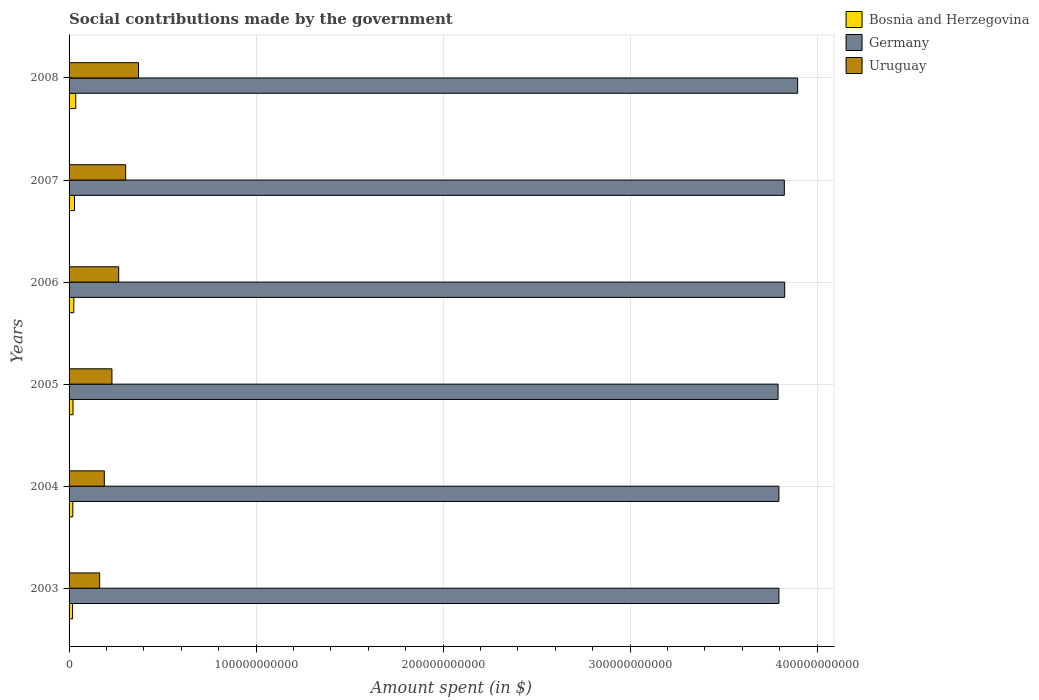Are the number of bars on each tick of the Y-axis equal?
Make the answer very short. Yes. What is the label of the 6th group of bars from the top?
Provide a short and direct response. 2003. In how many cases, is the number of bars for a given year not equal to the number of legend labels?
Offer a terse response. 0. What is the amount spent on social contributions in Bosnia and Herzegovina in 2005?
Give a very brief answer. 2.10e+09. Across all years, what is the maximum amount spent on social contributions in Germany?
Give a very brief answer. 3.90e+11. Across all years, what is the minimum amount spent on social contributions in Bosnia and Herzegovina?
Give a very brief answer. 1.88e+09. In which year was the amount spent on social contributions in Germany minimum?
Offer a terse response. 2005. What is the total amount spent on social contributions in Bosnia and Herzegovina in the graph?
Your answer should be very brief. 1.50e+1. What is the difference between the amount spent on social contributions in Uruguay in 2003 and that in 2007?
Make the answer very short. -1.39e+1. What is the difference between the amount spent on social contributions in Germany in 2004 and the amount spent on social contributions in Bosnia and Herzegovina in 2006?
Your answer should be very brief. 3.77e+11. What is the average amount spent on social contributions in Uruguay per year?
Your response must be concise. 2.53e+1. In the year 2004, what is the difference between the amount spent on social contributions in Bosnia and Herzegovina and amount spent on social contributions in Germany?
Your answer should be compact. -3.78e+11. What is the ratio of the amount spent on social contributions in Bosnia and Herzegovina in 2004 to that in 2006?
Offer a terse response. 0.79. Is the amount spent on social contributions in Uruguay in 2007 less than that in 2008?
Offer a terse response. Yes. Is the difference between the amount spent on social contributions in Bosnia and Herzegovina in 2005 and 2007 greater than the difference between the amount spent on social contributions in Germany in 2005 and 2007?
Offer a very short reply. Yes. What is the difference between the highest and the second highest amount spent on social contributions in Germany?
Your response must be concise. 6.92e+09. What is the difference between the highest and the lowest amount spent on social contributions in Uruguay?
Give a very brief answer. 2.08e+1. Is the sum of the amount spent on social contributions in Germany in 2003 and 2007 greater than the maximum amount spent on social contributions in Uruguay across all years?
Provide a succinct answer. Yes. What does the 3rd bar from the top in 2003 represents?
Provide a short and direct response. Bosnia and Herzegovina. Are all the bars in the graph horizontal?
Your response must be concise. Yes. How many years are there in the graph?
Offer a very short reply. 6. What is the difference between two consecutive major ticks on the X-axis?
Offer a terse response. 1.00e+11. Are the values on the major ticks of X-axis written in scientific E-notation?
Provide a short and direct response. No. Does the graph contain any zero values?
Keep it short and to the point. No. What is the title of the graph?
Make the answer very short. Social contributions made by the government. What is the label or title of the X-axis?
Give a very brief answer. Amount spent (in $). What is the Amount spent (in $) in Bosnia and Herzegovina in 2003?
Provide a short and direct response. 1.88e+09. What is the Amount spent (in $) of Germany in 2003?
Offer a terse response. 3.80e+11. What is the Amount spent (in $) of Uruguay in 2003?
Your answer should be very brief. 1.64e+1. What is the Amount spent (in $) in Bosnia and Herzegovina in 2004?
Your answer should be very brief. 2.00e+09. What is the Amount spent (in $) in Germany in 2004?
Ensure brevity in your answer.  3.80e+11. What is the Amount spent (in $) in Uruguay in 2004?
Your answer should be compact. 1.88e+1. What is the Amount spent (in $) of Bosnia and Herzegovina in 2005?
Provide a succinct answer. 2.10e+09. What is the Amount spent (in $) in Germany in 2005?
Provide a succinct answer. 3.79e+11. What is the Amount spent (in $) in Uruguay in 2005?
Give a very brief answer. 2.29e+1. What is the Amount spent (in $) in Bosnia and Herzegovina in 2006?
Offer a terse response. 2.54e+09. What is the Amount spent (in $) in Germany in 2006?
Offer a very short reply. 3.83e+11. What is the Amount spent (in $) of Uruguay in 2006?
Keep it short and to the point. 2.65e+1. What is the Amount spent (in $) of Bosnia and Herzegovina in 2007?
Your answer should be compact. 2.91e+09. What is the Amount spent (in $) in Germany in 2007?
Give a very brief answer. 3.82e+11. What is the Amount spent (in $) of Uruguay in 2007?
Ensure brevity in your answer.  3.03e+1. What is the Amount spent (in $) in Bosnia and Herzegovina in 2008?
Your answer should be compact. 3.57e+09. What is the Amount spent (in $) in Germany in 2008?
Make the answer very short. 3.90e+11. What is the Amount spent (in $) of Uruguay in 2008?
Provide a short and direct response. 3.71e+1. Across all years, what is the maximum Amount spent (in $) in Bosnia and Herzegovina?
Ensure brevity in your answer.  3.57e+09. Across all years, what is the maximum Amount spent (in $) in Germany?
Your answer should be compact. 3.90e+11. Across all years, what is the maximum Amount spent (in $) of Uruguay?
Your answer should be compact. 3.71e+1. Across all years, what is the minimum Amount spent (in $) of Bosnia and Herzegovina?
Provide a succinct answer. 1.88e+09. Across all years, what is the minimum Amount spent (in $) of Germany?
Provide a short and direct response. 3.79e+11. Across all years, what is the minimum Amount spent (in $) in Uruguay?
Ensure brevity in your answer.  1.64e+1. What is the total Amount spent (in $) in Bosnia and Herzegovina in the graph?
Your answer should be compact. 1.50e+1. What is the total Amount spent (in $) in Germany in the graph?
Give a very brief answer. 2.29e+12. What is the total Amount spent (in $) in Uruguay in the graph?
Provide a succinct answer. 1.52e+11. What is the difference between the Amount spent (in $) in Bosnia and Herzegovina in 2003 and that in 2004?
Make the answer very short. -1.27e+08. What is the difference between the Amount spent (in $) of Germany in 2003 and that in 2004?
Provide a succinct answer. 1.00e+07. What is the difference between the Amount spent (in $) in Uruguay in 2003 and that in 2004?
Provide a short and direct response. -2.50e+09. What is the difference between the Amount spent (in $) of Bosnia and Herzegovina in 2003 and that in 2005?
Offer a very short reply. -2.25e+08. What is the difference between the Amount spent (in $) of Germany in 2003 and that in 2005?
Your response must be concise. 4.50e+08. What is the difference between the Amount spent (in $) in Uruguay in 2003 and that in 2005?
Provide a succinct answer. -6.57e+09. What is the difference between the Amount spent (in $) in Bosnia and Herzegovina in 2003 and that in 2006?
Make the answer very short. -6.61e+08. What is the difference between the Amount spent (in $) in Germany in 2003 and that in 2006?
Your response must be concise. -3.09e+09. What is the difference between the Amount spent (in $) of Uruguay in 2003 and that in 2006?
Ensure brevity in your answer.  -1.02e+1. What is the difference between the Amount spent (in $) of Bosnia and Herzegovina in 2003 and that in 2007?
Give a very brief answer. -1.03e+09. What is the difference between the Amount spent (in $) of Germany in 2003 and that in 2007?
Make the answer very short. -2.90e+09. What is the difference between the Amount spent (in $) of Uruguay in 2003 and that in 2007?
Make the answer very short. -1.39e+1. What is the difference between the Amount spent (in $) of Bosnia and Herzegovina in 2003 and that in 2008?
Your answer should be compact. -1.69e+09. What is the difference between the Amount spent (in $) in Germany in 2003 and that in 2008?
Make the answer very short. -1.00e+1. What is the difference between the Amount spent (in $) in Uruguay in 2003 and that in 2008?
Keep it short and to the point. -2.08e+1. What is the difference between the Amount spent (in $) of Bosnia and Herzegovina in 2004 and that in 2005?
Provide a short and direct response. -9.74e+07. What is the difference between the Amount spent (in $) in Germany in 2004 and that in 2005?
Offer a very short reply. 4.40e+08. What is the difference between the Amount spent (in $) in Uruguay in 2004 and that in 2005?
Ensure brevity in your answer.  -4.07e+09. What is the difference between the Amount spent (in $) in Bosnia and Herzegovina in 2004 and that in 2006?
Ensure brevity in your answer.  -5.34e+08. What is the difference between the Amount spent (in $) of Germany in 2004 and that in 2006?
Your answer should be compact. -3.10e+09. What is the difference between the Amount spent (in $) of Uruguay in 2004 and that in 2006?
Your answer should be compact. -7.69e+09. What is the difference between the Amount spent (in $) of Bosnia and Herzegovina in 2004 and that in 2007?
Provide a succinct answer. -9.06e+08. What is the difference between the Amount spent (in $) of Germany in 2004 and that in 2007?
Keep it short and to the point. -2.91e+09. What is the difference between the Amount spent (in $) of Uruguay in 2004 and that in 2007?
Make the answer very short. -1.14e+1. What is the difference between the Amount spent (in $) of Bosnia and Herzegovina in 2004 and that in 2008?
Your answer should be compact. -1.57e+09. What is the difference between the Amount spent (in $) of Germany in 2004 and that in 2008?
Offer a very short reply. -1.00e+1. What is the difference between the Amount spent (in $) of Uruguay in 2004 and that in 2008?
Offer a terse response. -1.83e+1. What is the difference between the Amount spent (in $) of Bosnia and Herzegovina in 2005 and that in 2006?
Provide a succinct answer. -4.36e+08. What is the difference between the Amount spent (in $) of Germany in 2005 and that in 2006?
Make the answer very short. -3.54e+09. What is the difference between the Amount spent (in $) of Uruguay in 2005 and that in 2006?
Your answer should be very brief. -3.62e+09. What is the difference between the Amount spent (in $) of Bosnia and Herzegovina in 2005 and that in 2007?
Your answer should be compact. -8.09e+08. What is the difference between the Amount spent (in $) of Germany in 2005 and that in 2007?
Offer a very short reply. -3.35e+09. What is the difference between the Amount spent (in $) of Uruguay in 2005 and that in 2007?
Make the answer very short. -7.36e+09. What is the difference between the Amount spent (in $) in Bosnia and Herzegovina in 2005 and that in 2008?
Offer a terse response. -1.47e+09. What is the difference between the Amount spent (in $) of Germany in 2005 and that in 2008?
Ensure brevity in your answer.  -1.05e+1. What is the difference between the Amount spent (in $) in Uruguay in 2005 and that in 2008?
Provide a short and direct response. -1.42e+1. What is the difference between the Amount spent (in $) of Bosnia and Herzegovina in 2006 and that in 2007?
Your answer should be compact. -3.73e+08. What is the difference between the Amount spent (in $) of Germany in 2006 and that in 2007?
Your response must be concise. 1.90e+08. What is the difference between the Amount spent (in $) in Uruguay in 2006 and that in 2007?
Make the answer very short. -3.74e+09. What is the difference between the Amount spent (in $) of Bosnia and Herzegovina in 2006 and that in 2008?
Provide a short and direct response. -1.03e+09. What is the difference between the Amount spent (in $) in Germany in 2006 and that in 2008?
Offer a very short reply. -6.92e+09. What is the difference between the Amount spent (in $) in Uruguay in 2006 and that in 2008?
Ensure brevity in your answer.  -1.06e+1. What is the difference between the Amount spent (in $) in Bosnia and Herzegovina in 2007 and that in 2008?
Keep it short and to the point. -6.60e+08. What is the difference between the Amount spent (in $) in Germany in 2007 and that in 2008?
Offer a very short reply. -7.11e+09. What is the difference between the Amount spent (in $) of Uruguay in 2007 and that in 2008?
Offer a terse response. -6.83e+09. What is the difference between the Amount spent (in $) of Bosnia and Herzegovina in 2003 and the Amount spent (in $) of Germany in 2004?
Make the answer very short. -3.78e+11. What is the difference between the Amount spent (in $) in Bosnia and Herzegovina in 2003 and the Amount spent (in $) in Uruguay in 2004?
Your answer should be very brief. -1.70e+1. What is the difference between the Amount spent (in $) of Germany in 2003 and the Amount spent (in $) of Uruguay in 2004?
Ensure brevity in your answer.  3.61e+11. What is the difference between the Amount spent (in $) in Bosnia and Herzegovina in 2003 and the Amount spent (in $) in Germany in 2005?
Offer a very short reply. -3.77e+11. What is the difference between the Amount spent (in $) in Bosnia and Herzegovina in 2003 and the Amount spent (in $) in Uruguay in 2005?
Provide a short and direct response. -2.10e+1. What is the difference between the Amount spent (in $) in Germany in 2003 and the Amount spent (in $) in Uruguay in 2005?
Your response must be concise. 3.57e+11. What is the difference between the Amount spent (in $) of Bosnia and Herzegovina in 2003 and the Amount spent (in $) of Germany in 2006?
Your answer should be very brief. -3.81e+11. What is the difference between the Amount spent (in $) in Bosnia and Herzegovina in 2003 and the Amount spent (in $) in Uruguay in 2006?
Give a very brief answer. -2.47e+1. What is the difference between the Amount spent (in $) of Germany in 2003 and the Amount spent (in $) of Uruguay in 2006?
Make the answer very short. 3.53e+11. What is the difference between the Amount spent (in $) in Bosnia and Herzegovina in 2003 and the Amount spent (in $) in Germany in 2007?
Provide a short and direct response. -3.81e+11. What is the difference between the Amount spent (in $) in Bosnia and Herzegovina in 2003 and the Amount spent (in $) in Uruguay in 2007?
Make the answer very short. -2.84e+1. What is the difference between the Amount spent (in $) in Germany in 2003 and the Amount spent (in $) in Uruguay in 2007?
Provide a succinct answer. 3.49e+11. What is the difference between the Amount spent (in $) of Bosnia and Herzegovina in 2003 and the Amount spent (in $) of Germany in 2008?
Your answer should be very brief. -3.88e+11. What is the difference between the Amount spent (in $) of Bosnia and Herzegovina in 2003 and the Amount spent (in $) of Uruguay in 2008?
Your answer should be compact. -3.52e+1. What is the difference between the Amount spent (in $) in Germany in 2003 and the Amount spent (in $) in Uruguay in 2008?
Provide a short and direct response. 3.42e+11. What is the difference between the Amount spent (in $) of Bosnia and Herzegovina in 2004 and the Amount spent (in $) of Germany in 2005?
Give a very brief answer. -3.77e+11. What is the difference between the Amount spent (in $) of Bosnia and Herzegovina in 2004 and the Amount spent (in $) of Uruguay in 2005?
Ensure brevity in your answer.  -2.09e+1. What is the difference between the Amount spent (in $) of Germany in 2004 and the Amount spent (in $) of Uruguay in 2005?
Your answer should be compact. 3.57e+11. What is the difference between the Amount spent (in $) of Bosnia and Herzegovina in 2004 and the Amount spent (in $) of Germany in 2006?
Your answer should be compact. -3.81e+11. What is the difference between the Amount spent (in $) in Bosnia and Herzegovina in 2004 and the Amount spent (in $) in Uruguay in 2006?
Keep it short and to the point. -2.45e+1. What is the difference between the Amount spent (in $) of Germany in 2004 and the Amount spent (in $) of Uruguay in 2006?
Give a very brief answer. 3.53e+11. What is the difference between the Amount spent (in $) of Bosnia and Herzegovina in 2004 and the Amount spent (in $) of Germany in 2007?
Make the answer very short. -3.80e+11. What is the difference between the Amount spent (in $) of Bosnia and Herzegovina in 2004 and the Amount spent (in $) of Uruguay in 2007?
Provide a succinct answer. -2.83e+1. What is the difference between the Amount spent (in $) of Germany in 2004 and the Amount spent (in $) of Uruguay in 2007?
Offer a terse response. 3.49e+11. What is the difference between the Amount spent (in $) in Bosnia and Herzegovina in 2004 and the Amount spent (in $) in Germany in 2008?
Keep it short and to the point. -3.88e+11. What is the difference between the Amount spent (in $) in Bosnia and Herzegovina in 2004 and the Amount spent (in $) in Uruguay in 2008?
Keep it short and to the point. -3.51e+1. What is the difference between the Amount spent (in $) in Germany in 2004 and the Amount spent (in $) in Uruguay in 2008?
Give a very brief answer. 3.42e+11. What is the difference between the Amount spent (in $) of Bosnia and Herzegovina in 2005 and the Amount spent (in $) of Germany in 2006?
Give a very brief answer. -3.81e+11. What is the difference between the Amount spent (in $) of Bosnia and Herzegovina in 2005 and the Amount spent (in $) of Uruguay in 2006?
Your answer should be very brief. -2.44e+1. What is the difference between the Amount spent (in $) in Germany in 2005 and the Amount spent (in $) in Uruguay in 2006?
Your response must be concise. 3.53e+11. What is the difference between the Amount spent (in $) in Bosnia and Herzegovina in 2005 and the Amount spent (in $) in Germany in 2007?
Keep it short and to the point. -3.80e+11. What is the difference between the Amount spent (in $) in Bosnia and Herzegovina in 2005 and the Amount spent (in $) in Uruguay in 2007?
Provide a short and direct response. -2.82e+1. What is the difference between the Amount spent (in $) of Germany in 2005 and the Amount spent (in $) of Uruguay in 2007?
Your response must be concise. 3.49e+11. What is the difference between the Amount spent (in $) of Bosnia and Herzegovina in 2005 and the Amount spent (in $) of Germany in 2008?
Provide a short and direct response. -3.87e+11. What is the difference between the Amount spent (in $) of Bosnia and Herzegovina in 2005 and the Amount spent (in $) of Uruguay in 2008?
Your response must be concise. -3.50e+1. What is the difference between the Amount spent (in $) in Germany in 2005 and the Amount spent (in $) in Uruguay in 2008?
Keep it short and to the point. 3.42e+11. What is the difference between the Amount spent (in $) in Bosnia and Herzegovina in 2006 and the Amount spent (in $) in Germany in 2007?
Make the answer very short. -3.80e+11. What is the difference between the Amount spent (in $) in Bosnia and Herzegovina in 2006 and the Amount spent (in $) in Uruguay in 2007?
Provide a succinct answer. -2.77e+1. What is the difference between the Amount spent (in $) of Germany in 2006 and the Amount spent (in $) of Uruguay in 2007?
Provide a short and direct response. 3.52e+11. What is the difference between the Amount spent (in $) in Bosnia and Herzegovina in 2006 and the Amount spent (in $) in Germany in 2008?
Offer a very short reply. -3.87e+11. What is the difference between the Amount spent (in $) in Bosnia and Herzegovina in 2006 and the Amount spent (in $) in Uruguay in 2008?
Your answer should be very brief. -3.46e+1. What is the difference between the Amount spent (in $) of Germany in 2006 and the Amount spent (in $) of Uruguay in 2008?
Ensure brevity in your answer.  3.46e+11. What is the difference between the Amount spent (in $) in Bosnia and Herzegovina in 2007 and the Amount spent (in $) in Germany in 2008?
Your response must be concise. -3.87e+11. What is the difference between the Amount spent (in $) in Bosnia and Herzegovina in 2007 and the Amount spent (in $) in Uruguay in 2008?
Provide a short and direct response. -3.42e+1. What is the difference between the Amount spent (in $) of Germany in 2007 and the Amount spent (in $) of Uruguay in 2008?
Keep it short and to the point. 3.45e+11. What is the average Amount spent (in $) in Bosnia and Herzegovina per year?
Offer a very short reply. 2.50e+09. What is the average Amount spent (in $) in Germany per year?
Your response must be concise. 3.82e+11. What is the average Amount spent (in $) of Uruguay per year?
Your answer should be very brief. 2.53e+1. In the year 2003, what is the difference between the Amount spent (in $) in Bosnia and Herzegovina and Amount spent (in $) in Germany?
Your answer should be very brief. -3.78e+11. In the year 2003, what is the difference between the Amount spent (in $) of Bosnia and Herzegovina and Amount spent (in $) of Uruguay?
Offer a very short reply. -1.45e+1. In the year 2003, what is the difference between the Amount spent (in $) of Germany and Amount spent (in $) of Uruguay?
Provide a short and direct response. 3.63e+11. In the year 2004, what is the difference between the Amount spent (in $) in Bosnia and Herzegovina and Amount spent (in $) in Germany?
Offer a very short reply. -3.78e+11. In the year 2004, what is the difference between the Amount spent (in $) in Bosnia and Herzegovina and Amount spent (in $) in Uruguay?
Keep it short and to the point. -1.68e+1. In the year 2004, what is the difference between the Amount spent (in $) of Germany and Amount spent (in $) of Uruguay?
Your answer should be very brief. 3.61e+11. In the year 2005, what is the difference between the Amount spent (in $) of Bosnia and Herzegovina and Amount spent (in $) of Germany?
Keep it short and to the point. -3.77e+11. In the year 2005, what is the difference between the Amount spent (in $) of Bosnia and Herzegovina and Amount spent (in $) of Uruguay?
Offer a very short reply. -2.08e+1. In the year 2005, what is the difference between the Amount spent (in $) of Germany and Amount spent (in $) of Uruguay?
Your answer should be very brief. 3.56e+11. In the year 2006, what is the difference between the Amount spent (in $) in Bosnia and Herzegovina and Amount spent (in $) in Germany?
Your response must be concise. -3.80e+11. In the year 2006, what is the difference between the Amount spent (in $) in Bosnia and Herzegovina and Amount spent (in $) in Uruguay?
Provide a succinct answer. -2.40e+1. In the year 2006, what is the difference between the Amount spent (in $) of Germany and Amount spent (in $) of Uruguay?
Make the answer very short. 3.56e+11. In the year 2007, what is the difference between the Amount spent (in $) of Bosnia and Herzegovina and Amount spent (in $) of Germany?
Provide a short and direct response. -3.80e+11. In the year 2007, what is the difference between the Amount spent (in $) in Bosnia and Herzegovina and Amount spent (in $) in Uruguay?
Provide a short and direct response. -2.74e+1. In the year 2007, what is the difference between the Amount spent (in $) of Germany and Amount spent (in $) of Uruguay?
Ensure brevity in your answer.  3.52e+11. In the year 2008, what is the difference between the Amount spent (in $) of Bosnia and Herzegovina and Amount spent (in $) of Germany?
Provide a succinct answer. -3.86e+11. In the year 2008, what is the difference between the Amount spent (in $) in Bosnia and Herzegovina and Amount spent (in $) in Uruguay?
Your answer should be very brief. -3.35e+1. In the year 2008, what is the difference between the Amount spent (in $) of Germany and Amount spent (in $) of Uruguay?
Your response must be concise. 3.52e+11. What is the ratio of the Amount spent (in $) in Bosnia and Herzegovina in 2003 to that in 2004?
Your answer should be compact. 0.94. What is the ratio of the Amount spent (in $) of Germany in 2003 to that in 2004?
Make the answer very short. 1. What is the ratio of the Amount spent (in $) in Uruguay in 2003 to that in 2004?
Keep it short and to the point. 0.87. What is the ratio of the Amount spent (in $) of Bosnia and Herzegovina in 2003 to that in 2005?
Your answer should be compact. 0.89. What is the ratio of the Amount spent (in $) of Germany in 2003 to that in 2005?
Make the answer very short. 1. What is the ratio of the Amount spent (in $) of Uruguay in 2003 to that in 2005?
Make the answer very short. 0.71. What is the ratio of the Amount spent (in $) of Bosnia and Herzegovina in 2003 to that in 2006?
Your answer should be very brief. 0.74. What is the ratio of the Amount spent (in $) of Uruguay in 2003 to that in 2006?
Ensure brevity in your answer.  0.62. What is the ratio of the Amount spent (in $) in Bosnia and Herzegovina in 2003 to that in 2007?
Your answer should be compact. 0.64. What is the ratio of the Amount spent (in $) in Germany in 2003 to that in 2007?
Your answer should be compact. 0.99. What is the ratio of the Amount spent (in $) of Uruguay in 2003 to that in 2007?
Ensure brevity in your answer.  0.54. What is the ratio of the Amount spent (in $) of Bosnia and Herzegovina in 2003 to that in 2008?
Your response must be concise. 0.53. What is the ratio of the Amount spent (in $) of Germany in 2003 to that in 2008?
Provide a short and direct response. 0.97. What is the ratio of the Amount spent (in $) in Uruguay in 2003 to that in 2008?
Make the answer very short. 0.44. What is the ratio of the Amount spent (in $) of Bosnia and Herzegovina in 2004 to that in 2005?
Ensure brevity in your answer.  0.95. What is the ratio of the Amount spent (in $) of Uruguay in 2004 to that in 2005?
Your answer should be compact. 0.82. What is the ratio of the Amount spent (in $) of Bosnia and Herzegovina in 2004 to that in 2006?
Provide a short and direct response. 0.79. What is the ratio of the Amount spent (in $) in Uruguay in 2004 to that in 2006?
Your answer should be compact. 0.71. What is the ratio of the Amount spent (in $) in Bosnia and Herzegovina in 2004 to that in 2007?
Give a very brief answer. 0.69. What is the ratio of the Amount spent (in $) in Uruguay in 2004 to that in 2007?
Provide a succinct answer. 0.62. What is the ratio of the Amount spent (in $) in Bosnia and Herzegovina in 2004 to that in 2008?
Your answer should be very brief. 0.56. What is the ratio of the Amount spent (in $) of Germany in 2004 to that in 2008?
Offer a terse response. 0.97. What is the ratio of the Amount spent (in $) in Uruguay in 2004 to that in 2008?
Provide a short and direct response. 0.51. What is the ratio of the Amount spent (in $) of Bosnia and Herzegovina in 2005 to that in 2006?
Make the answer very short. 0.83. What is the ratio of the Amount spent (in $) of Uruguay in 2005 to that in 2006?
Offer a very short reply. 0.86. What is the ratio of the Amount spent (in $) of Bosnia and Herzegovina in 2005 to that in 2007?
Make the answer very short. 0.72. What is the ratio of the Amount spent (in $) of Germany in 2005 to that in 2007?
Your answer should be very brief. 0.99. What is the ratio of the Amount spent (in $) of Uruguay in 2005 to that in 2007?
Your response must be concise. 0.76. What is the ratio of the Amount spent (in $) of Bosnia and Herzegovina in 2005 to that in 2008?
Provide a succinct answer. 0.59. What is the ratio of the Amount spent (in $) in Germany in 2005 to that in 2008?
Your answer should be very brief. 0.97. What is the ratio of the Amount spent (in $) in Uruguay in 2005 to that in 2008?
Your answer should be compact. 0.62. What is the ratio of the Amount spent (in $) in Bosnia and Herzegovina in 2006 to that in 2007?
Give a very brief answer. 0.87. What is the ratio of the Amount spent (in $) of Uruguay in 2006 to that in 2007?
Your response must be concise. 0.88. What is the ratio of the Amount spent (in $) in Bosnia and Herzegovina in 2006 to that in 2008?
Your answer should be very brief. 0.71. What is the ratio of the Amount spent (in $) of Germany in 2006 to that in 2008?
Provide a short and direct response. 0.98. What is the ratio of the Amount spent (in $) in Uruguay in 2006 to that in 2008?
Offer a terse response. 0.72. What is the ratio of the Amount spent (in $) in Bosnia and Herzegovina in 2007 to that in 2008?
Offer a terse response. 0.82. What is the ratio of the Amount spent (in $) of Germany in 2007 to that in 2008?
Provide a succinct answer. 0.98. What is the ratio of the Amount spent (in $) of Uruguay in 2007 to that in 2008?
Your answer should be compact. 0.82. What is the difference between the highest and the second highest Amount spent (in $) in Bosnia and Herzegovina?
Offer a very short reply. 6.60e+08. What is the difference between the highest and the second highest Amount spent (in $) of Germany?
Provide a succinct answer. 6.92e+09. What is the difference between the highest and the second highest Amount spent (in $) of Uruguay?
Ensure brevity in your answer.  6.83e+09. What is the difference between the highest and the lowest Amount spent (in $) of Bosnia and Herzegovina?
Your answer should be very brief. 1.69e+09. What is the difference between the highest and the lowest Amount spent (in $) in Germany?
Provide a short and direct response. 1.05e+1. What is the difference between the highest and the lowest Amount spent (in $) in Uruguay?
Your response must be concise. 2.08e+1. 